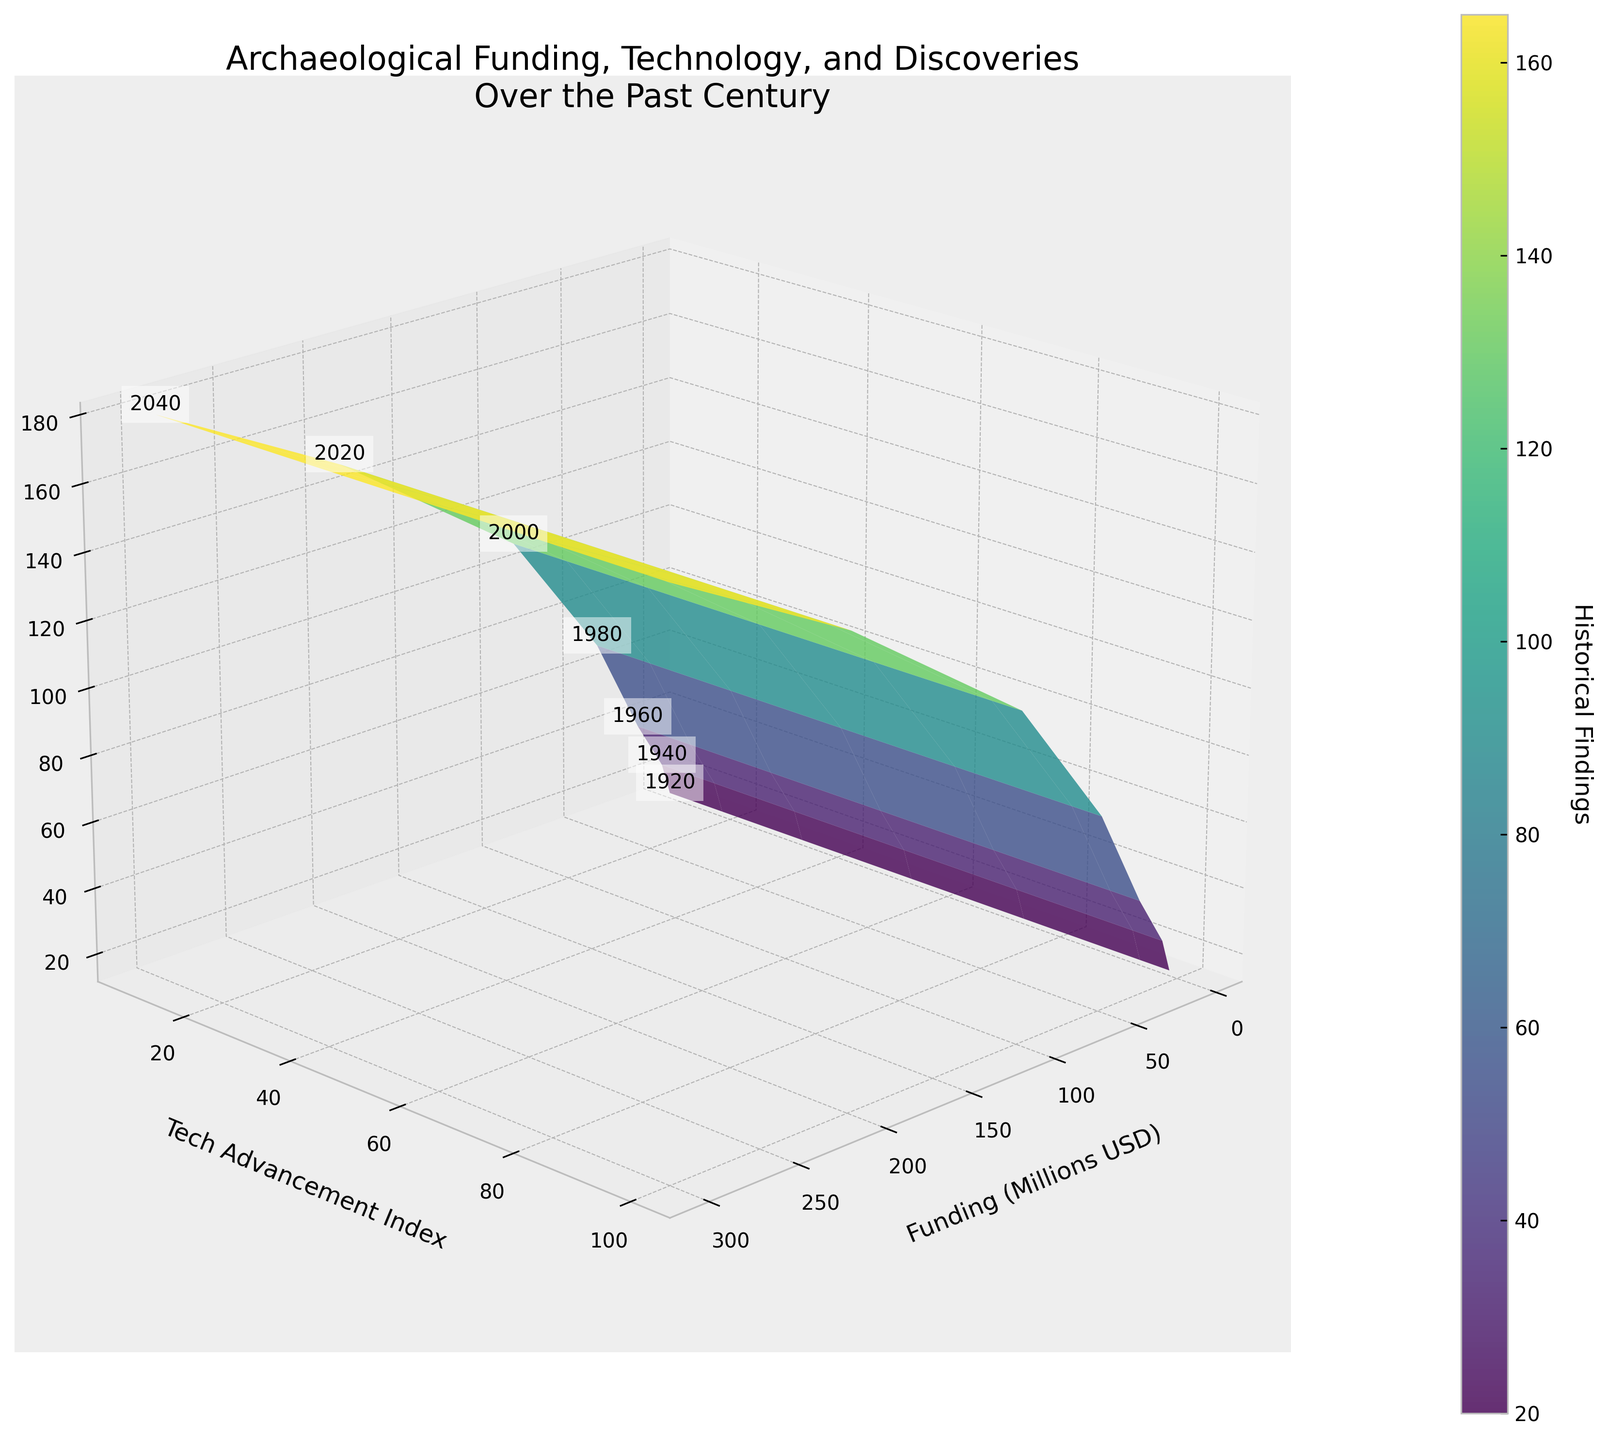What's the title of the plot? The title is located at the top of the plot and reads: "Archaeological Funding, Technology, and Discoveries Over the Past Century"
Answer: Archaeological Funding, Technology, and Discoveries Over the Past Century How are the axes labeled? The x-axis is labeled "Funding (Millions USD)", the y-axis is labeled "Tech Advancement Index", and the z-axis is labeled "Historical Findings". These labels are located near each respective axis.
Answer: Funding (Millions USD), Tech Advancement Index, Historical Findings How many data points are present in the figure? There are seven labeled data points in the figure, each corresponding to specific years from 1920 to 2040 in 20-year intervals.
Answer: 7 Which year had the lowest technological advancement index? By examining the labels on the y-axis and the annotations in the plot, the year with the lowest technological advancement index, which is 10, corresponds to 1920.
Answer: 1920 What color represents the highest value of historical findings? The surface plot uses a color gradient to depict the values of historical findings. The highest value is found in the region where the color transitions to a bright yellow/green.
Answer: Bright yellow/green What is the funding amount in the year 2000? The year 2000 is annotated on the plot, and the corresponding x-axis value (Funding) reads 100 million USD.
Answer: 100 million USD What is the average tech advancement index between 1920 and 2020? The Tech Advancement Index values for the years 1920, 1940, 1960, 1980, 2000, and 2020 are 10, 20, 35, 55, 75, and 95 respectively. Summing these values gives 290, and dividing by the number of years (6) results in an average index of 48.33.
Answer: 48.33 Which year shows the highest number of historical findings? On the plot, the z-axis represents historical findings, and the year with the label corresponding to the highest z-value, which is 150, matches the year 2020.
Answer: 2020 Between 1980 and 2000, how much did the funding increase, and what was the change in tech advancement index? From the visual annotations, funding in 1980 was 50 million USD and increased to 100 million USD in 2000, an increase of 50 million USD. The tech advancement index went from 55 in 1980 to 75 in 2000, an increase of 20.
Answer: Funding increase: 50 million USD, Tech Advancement Index increase: 20 What is the relationship between funding and historical findings as shown by the plot? The plot indicates that as funding increases, the number of historical findings also increases. This is visualized by the upward trend in the z-axis values as the x-axis values increase.
Answer: Positive correlation 